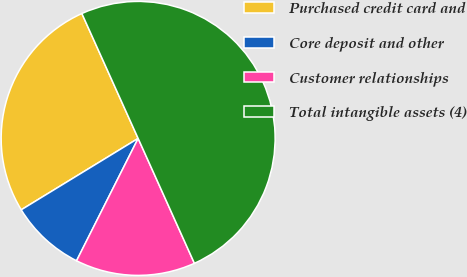Convert chart. <chart><loc_0><loc_0><loc_500><loc_500><pie_chart><fcel>Purchased credit card and<fcel>Core deposit and other<fcel>Customer relationships<fcel>Total intangible assets (4)<nl><fcel>26.99%<fcel>8.85%<fcel>14.16%<fcel>50.0%<nl></chart> 